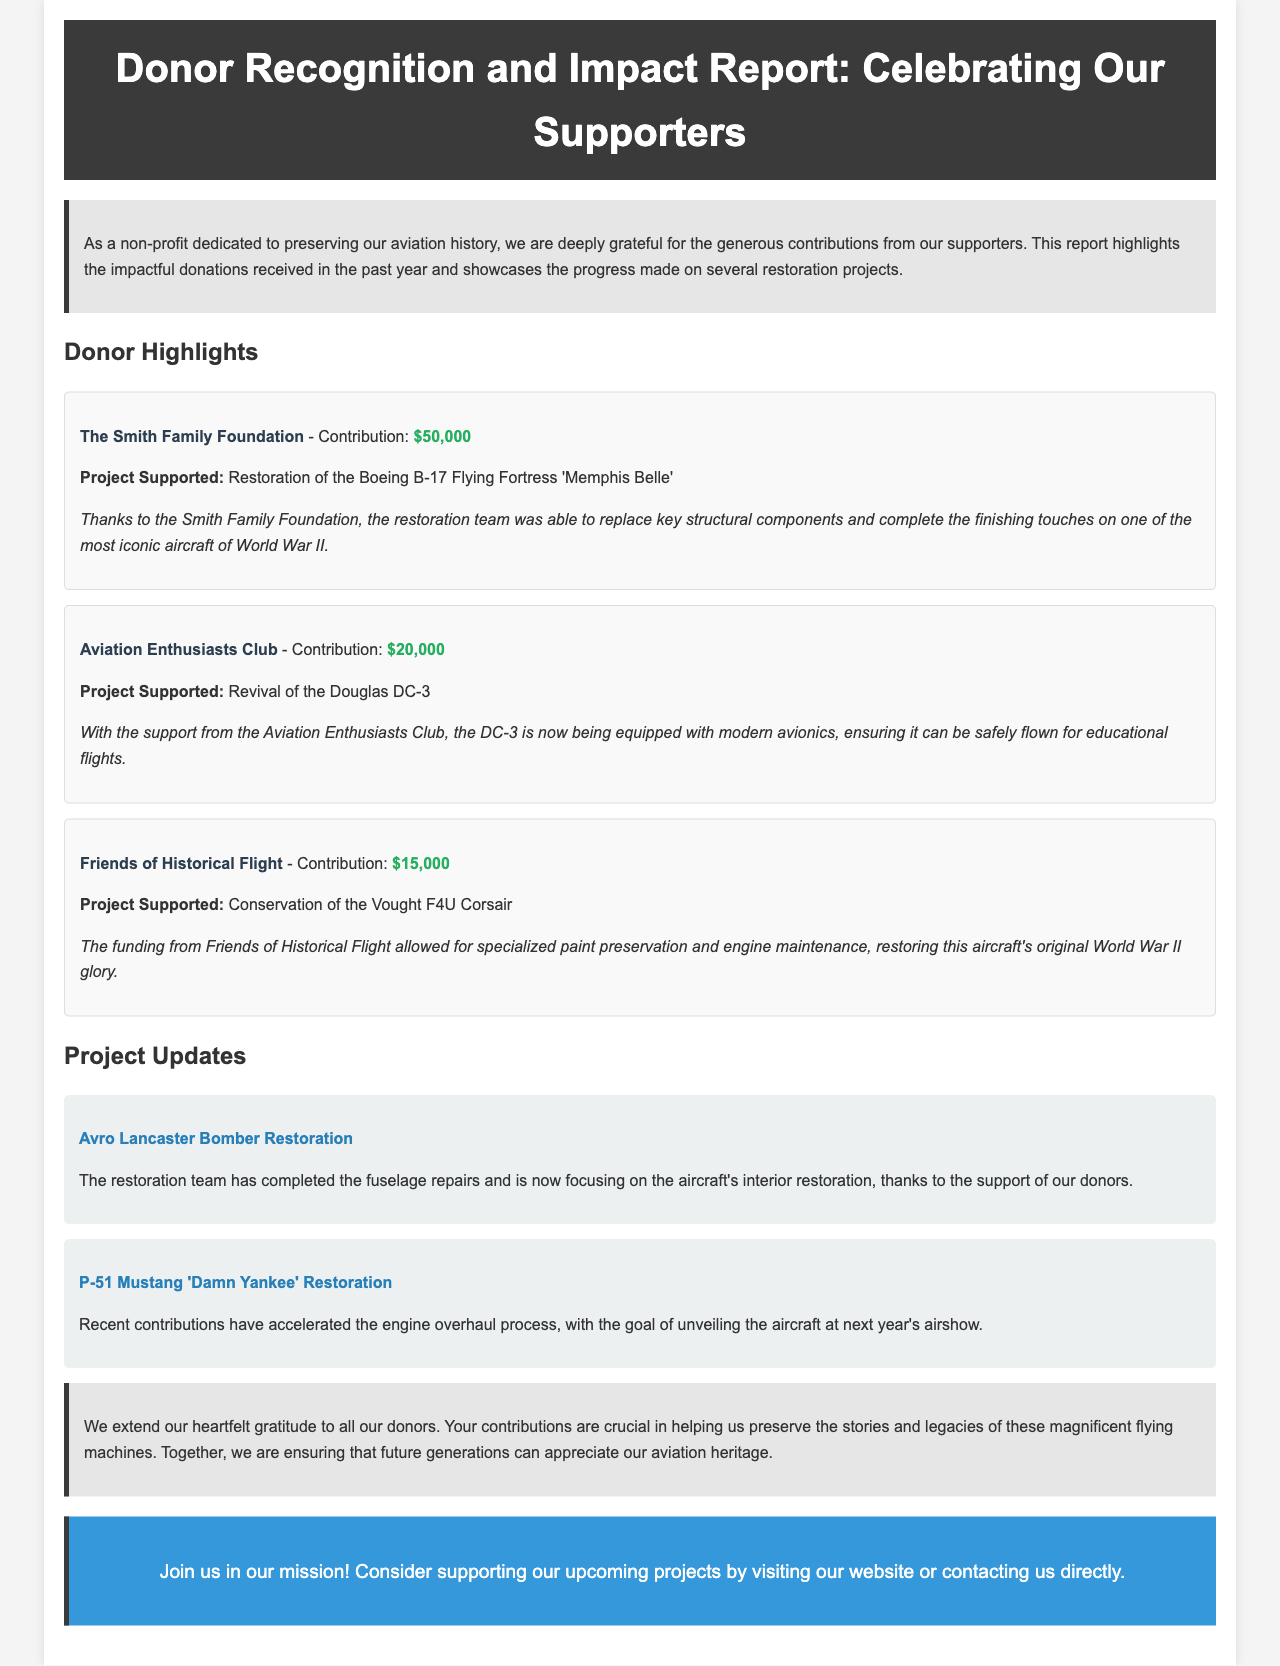What is the title of the report? The title of the report is stated in the header section of the document.
Answer: Donor Recognition and Impact Report: Celebrating Our Supporters Who is the donor that contributed $50,000? The document highlights specific donors and their contributions, including the one that contributed $50,000.
Answer: The Smith Family Foundation What project did the Aviation Enthusiasts Club support? The document specifies which project was supported by each donor, including the Aviation Enthusiasts Club.
Answer: Revival of the Douglas DC-3 How much funding did Friends of Historical Flight provide? The amount funded by each donor is listed in the document under their name.
Answer: $15,000 What is the focus of the Avro Lancaster Bomber Restoration project? The project updates section describes the current focus of different restoration projects.
Answer: Interior restoration What is the goal for the P-51 Mustang 'Damn Yankee' Restoration? The project updates provide the future objectives for each restoration project mentioned.
Answer: Unveiling the aircraft at next year's airshow What type of document is this? The structure and content indicate the type of document based on its intent and format.
Answer: Newsletter What color represents the donor highlights section? The document includes details regarding the design and layout, specifying colors for different sections.
Answer: Light gray 